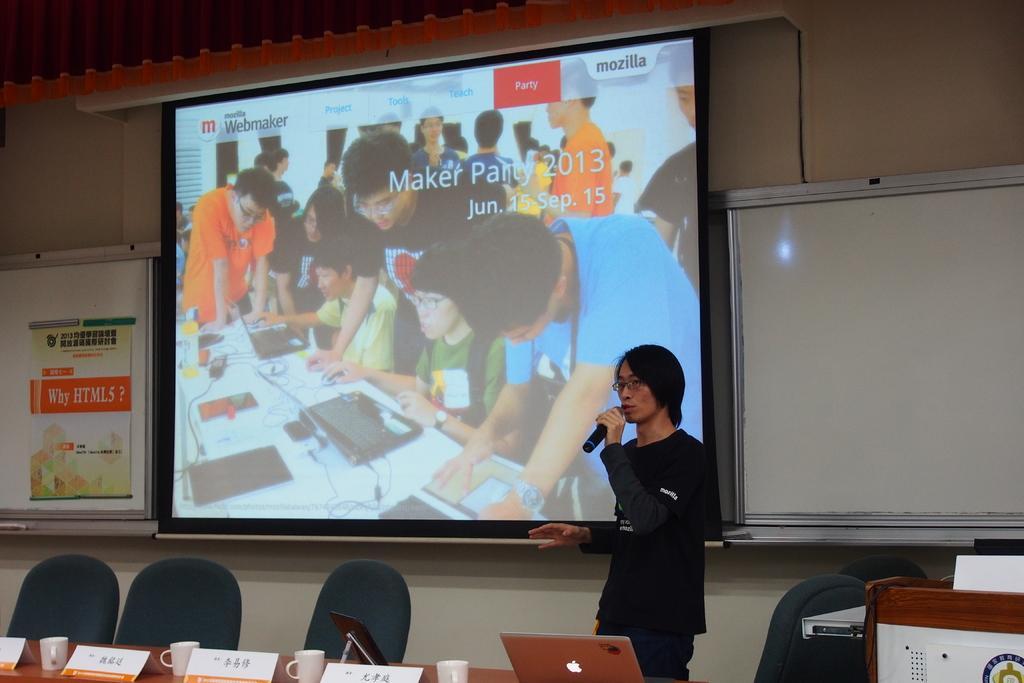Please provide a concise description of this image. In this picture i could see a person holding a mic and talking. He is dressed in black, in the background i could see a big screen in which the people are looking to the laptops and working on them, in the right side there is a white board and in the left bottom of the picture there are some green chairs and table and white colored cups and name plate and even a laptop. In the right corner of the picture there is a podium. 